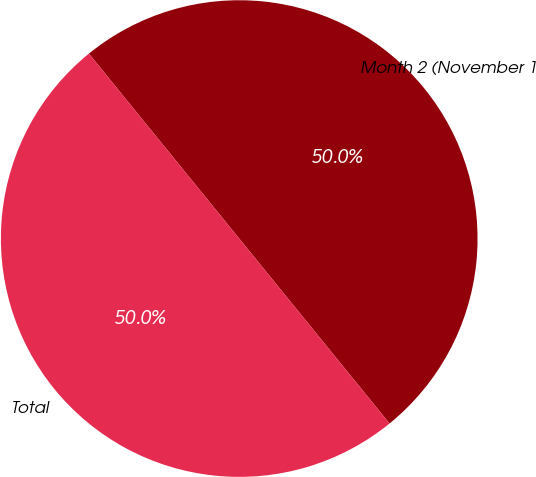Convert chart to OTSL. <chart><loc_0><loc_0><loc_500><loc_500><pie_chart><fcel>Month 2 (November 1<fcel>Total<nl><fcel>50.0%<fcel>50.0%<nl></chart> 